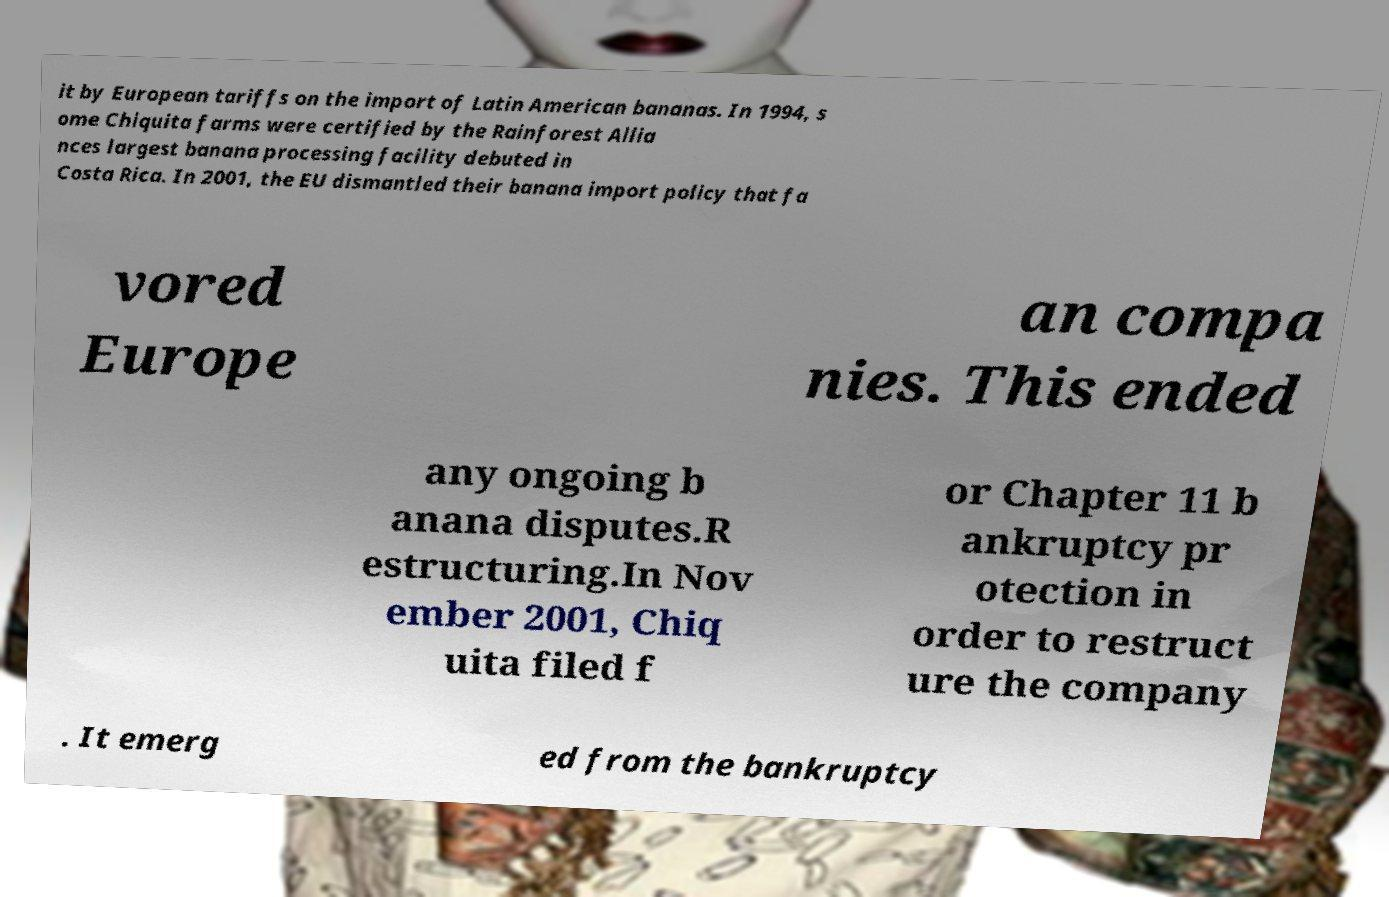Please read and relay the text visible in this image. What does it say? it by European tariffs on the import of Latin American bananas. In 1994, s ome Chiquita farms were certified by the Rainforest Allia nces largest banana processing facility debuted in Costa Rica. In 2001, the EU dismantled their banana import policy that fa vored Europe an compa nies. This ended any ongoing b anana disputes.R estructuring.In Nov ember 2001, Chiq uita filed f or Chapter 11 b ankruptcy pr otection in order to restruct ure the company . It emerg ed from the bankruptcy 